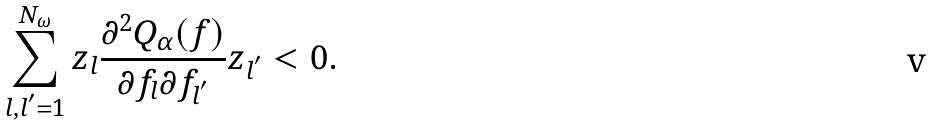<formula> <loc_0><loc_0><loc_500><loc_500>\sum _ { l , l ^ { ^ { \prime } } = 1 } ^ { N _ { \omega } } z _ { l } \frac { \partial ^ { 2 } Q _ { \alpha } ( f ) } { \partial f _ { l } \partial f _ { l ^ { ^ { \prime } } } } z _ { l ^ { ^ { \prime } } } < 0 .</formula> 